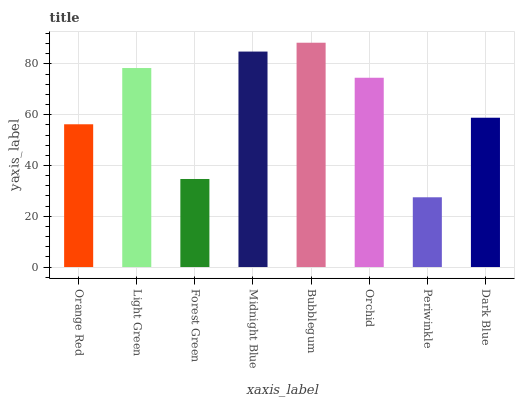Is Periwinkle the minimum?
Answer yes or no. Yes. Is Bubblegum the maximum?
Answer yes or no. Yes. Is Light Green the minimum?
Answer yes or no. No. Is Light Green the maximum?
Answer yes or no. No. Is Light Green greater than Orange Red?
Answer yes or no. Yes. Is Orange Red less than Light Green?
Answer yes or no. Yes. Is Orange Red greater than Light Green?
Answer yes or no. No. Is Light Green less than Orange Red?
Answer yes or no. No. Is Orchid the high median?
Answer yes or no. Yes. Is Dark Blue the low median?
Answer yes or no. Yes. Is Bubblegum the high median?
Answer yes or no. No. Is Midnight Blue the low median?
Answer yes or no. No. 